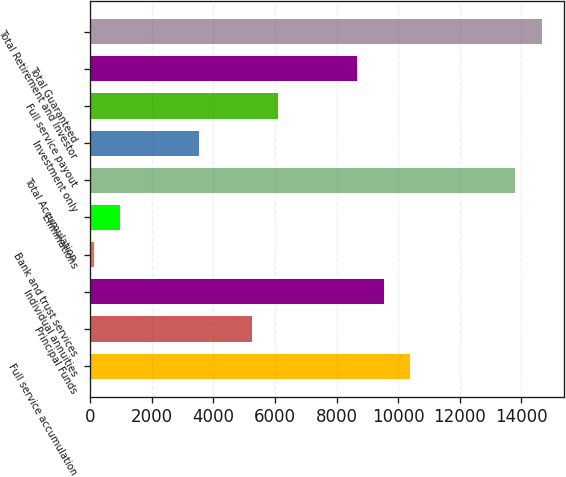Convert chart. <chart><loc_0><loc_0><loc_500><loc_500><bar_chart><fcel>Full service accumulation<fcel>Principal Funds<fcel>Individual annuities<fcel>Bank and trust services<fcel>Eliminations<fcel>Total Accumulation<fcel>Investment only<fcel>Full service payout<fcel>Total Guaranteed<fcel>Total Retirement and Investor<nl><fcel>10384.7<fcel>5242.62<fcel>9527.72<fcel>100.5<fcel>957.52<fcel>13812.8<fcel>3528.58<fcel>6099.64<fcel>8670.7<fcel>14669.8<nl></chart> 